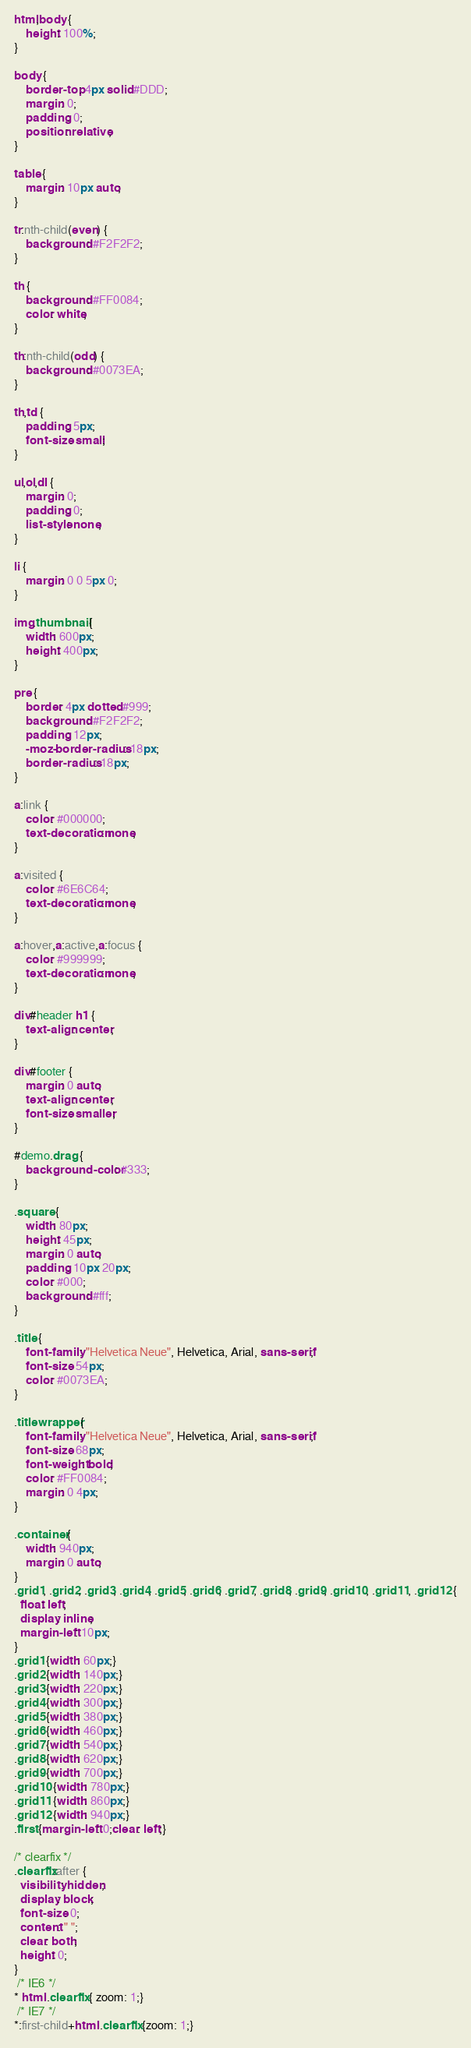<code> <loc_0><loc_0><loc_500><loc_500><_CSS_>html,body {
	height: 100%;
}

body {
	border-top: 4px solid #DDD;
	margin: 0;
	padding: 0;
	position: relative;
}

table {
	margin: 10px auto;
}

tr:nth-child(even) {
	background: #F2F2F2;
}

th {
	background: #FF0084;
	color: white;
}

th:nth-child(odd) {
	background: #0073EA;
}

th,td {
	padding: 5px;
	font-size: small;
}

ul,ol,dl {
	margin: 0;
	padding: 0;
	list-style: none;
}

li {
	margin: 0 0 5px 0;
}

img.thumbnail {
	width: 600px;
	height: 400px;
}

pre {
	border: 4px dotted #999;
	background: #F2F2F2;
	padding: 12px;
	-moz-border-radius: 18px;
	border-radius: 18px;
}

a:link {
	color: #000000;
	text-decoration: none;
}

a:visited {
	color: #6E6C64;
	text-decoration: none;
}

a:hover,a:active,a:focus {
	color: #999999;
	text-decoration: none;
}

div#header h1 {
	text-align: center;
}

div#footer {
	margin: 0 auto;
	text-align: center;
	font-size: smaller;
}

#demo.drag {
	background-color: #333;
}

.square {
	width: 80px;
	height: 45px;
	margin: 0 auto;
	padding: 10px 20px;
	color: #000;
	background: #fff;
}

.title {
	font-family: "Helvetica Neue", Helvetica, Arial, sans-serif;
	font-size: 54px;
	color: #0073EA;
}

.titlewrapper {
	font-family: "Helvetica Neue", Helvetica, Arial, sans-serif;
	font-size: 68px;
	font-weight: bold;
	color: #FF0084;
	margin: 0 4px;
}

.container {
	width: 940px;
	margin: 0 auto;
}
.grid1, .grid2, .grid3, .grid4, .grid5, .grid6, .grid7, .grid8, .grid9, .grid10, .grid11, .grid12 {
  float: left;
  display: inline;
  margin-left: 10px;
}
.grid1 {width: 60px;}
.grid2 {width: 140px;}
.grid3 {width: 220px;}
.grid4 {width: 300px;}
.grid5 {width: 380px;}
.grid6 {width: 460px;}
.grid7 {width: 540px;}
.grid8 {width: 620px;}
.grid9 {width: 700px;}
.grid10 {width: 780px;}
.grid11 {width: 860px;}
.grid12 {width: 940px;}
.first {margin-left: 0;clear: left;}

/* clearfix */
.clearfix:after {
  visibility: hidden;
  display: block;
  font-size: 0;
  content: " ";
  clear: both;
  height: 0;
}
 /* IE6 */
* html .clearfix { zoom: 1;}
 /* IE7 */
*:first-child+html .clearfix {zoom: 1;}</code> 